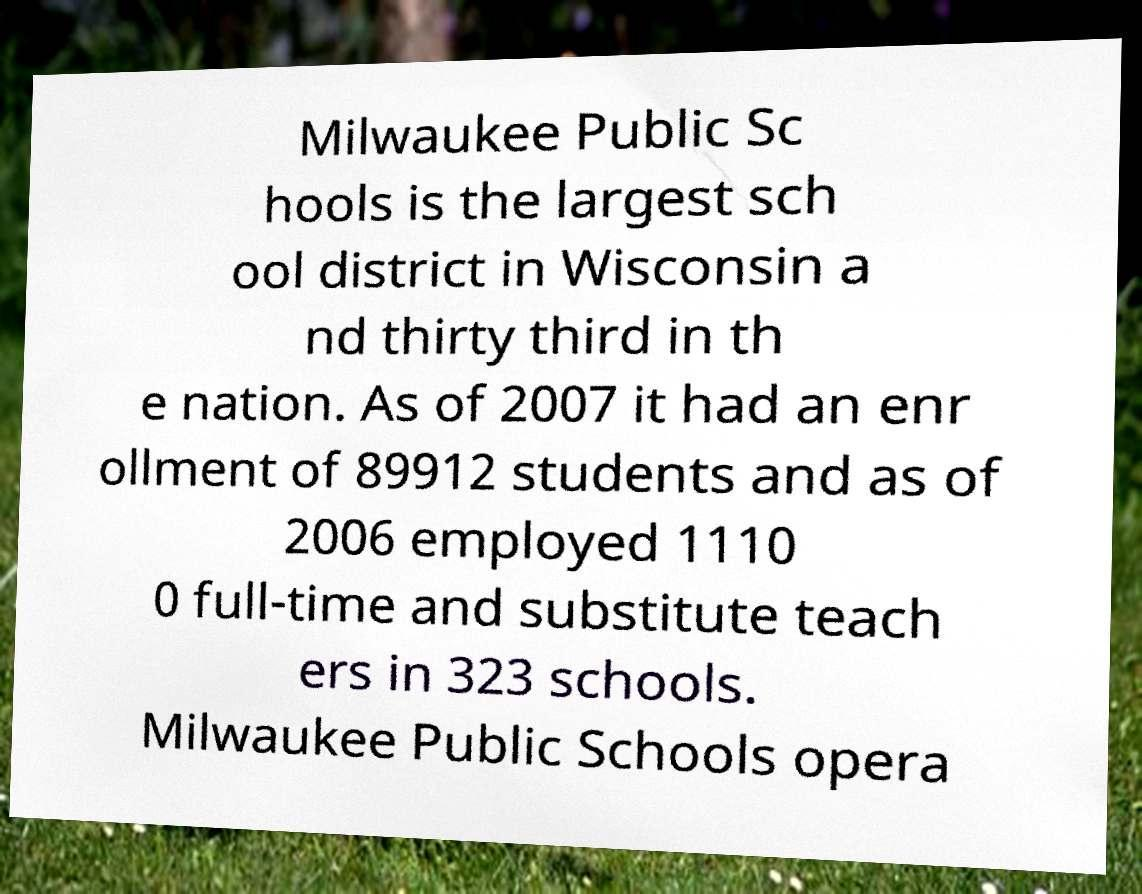Can you accurately transcribe the text from the provided image for me? Milwaukee Public Sc hools is the largest sch ool district in Wisconsin a nd thirty third in th e nation. As of 2007 it had an enr ollment of 89912 students and as of 2006 employed 1110 0 full-time and substitute teach ers in 323 schools. Milwaukee Public Schools opera 